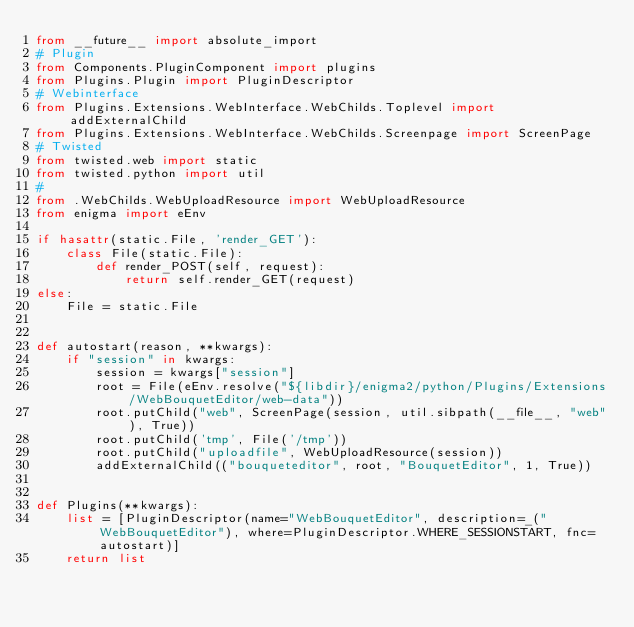Convert code to text. <code><loc_0><loc_0><loc_500><loc_500><_Python_>from __future__ import absolute_import
# Plugin
from Components.PluginComponent import plugins
from Plugins.Plugin import PluginDescriptor
# Webinterface
from Plugins.Extensions.WebInterface.WebChilds.Toplevel import addExternalChild
from Plugins.Extensions.WebInterface.WebChilds.Screenpage import ScreenPage
# Twisted
from twisted.web import static
from twisted.python import util
#
from .WebChilds.WebUploadResource import WebUploadResource
from enigma import eEnv

if hasattr(static.File, 'render_GET'):
	class File(static.File):
		def render_POST(self, request):
			return self.render_GET(request)
else:
	File = static.File


def autostart(reason, **kwargs):
	if "session" in kwargs:
		session = kwargs["session"]
		root = File(eEnv.resolve("${libdir}/enigma2/python/Plugins/Extensions/WebBouquetEditor/web-data"))
		root.putChild("web", ScreenPage(session, util.sibpath(__file__, "web"), True))
		root.putChild('tmp', File('/tmp'))
		root.putChild("uploadfile", WebUploadResource(session))
		addExternalChild(("bouqueteditor", root, "BouquetEditor", 1, True))


def Plugins(**kwargs):
	list = [PluginDescriptor(name="WebBouquetEditor", description=_("WebBouquetEditor"), where=PluginDescriptor.WHERE_SESSIONSTART, fnc=autostart)]
	return list
</code> 